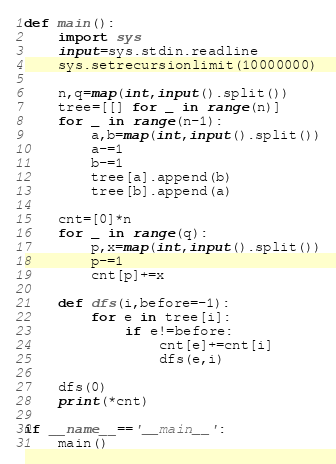Convert code to text. <code><loc_0><loc_0><loc_500><loc_500><_Python_>def main():
    import sys
    input=sys.stdin.readline
    sys.setrecursionlimit(10000000)
    
    n,q=map(int,input().split())
    tree=[[] for _ in range(n)]
    for _ in range(n-1):
        a,b=map(int,input().split())
        a-=1
        b-=1
        tree[a].append(b)
        tree[b].append(a)
    
    cnt=[0]*n
    for _ in range(q):
        p,x=map(int,input().split())
        p-=1
        cnt[p]+=x
    
    def dfs(i,before=-1):
        for e in tree[i]:
            if e!=before:
                cnt[e]+=cnt[i]
                dfs(e,i)
                
    dfs(0)   
    print(*cnt)

if __name__=='__main__':
    main()

</code> 